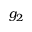<formula> <loc_0><loc_0><loc_500><loc_500>g _ { 2 }</formula> 